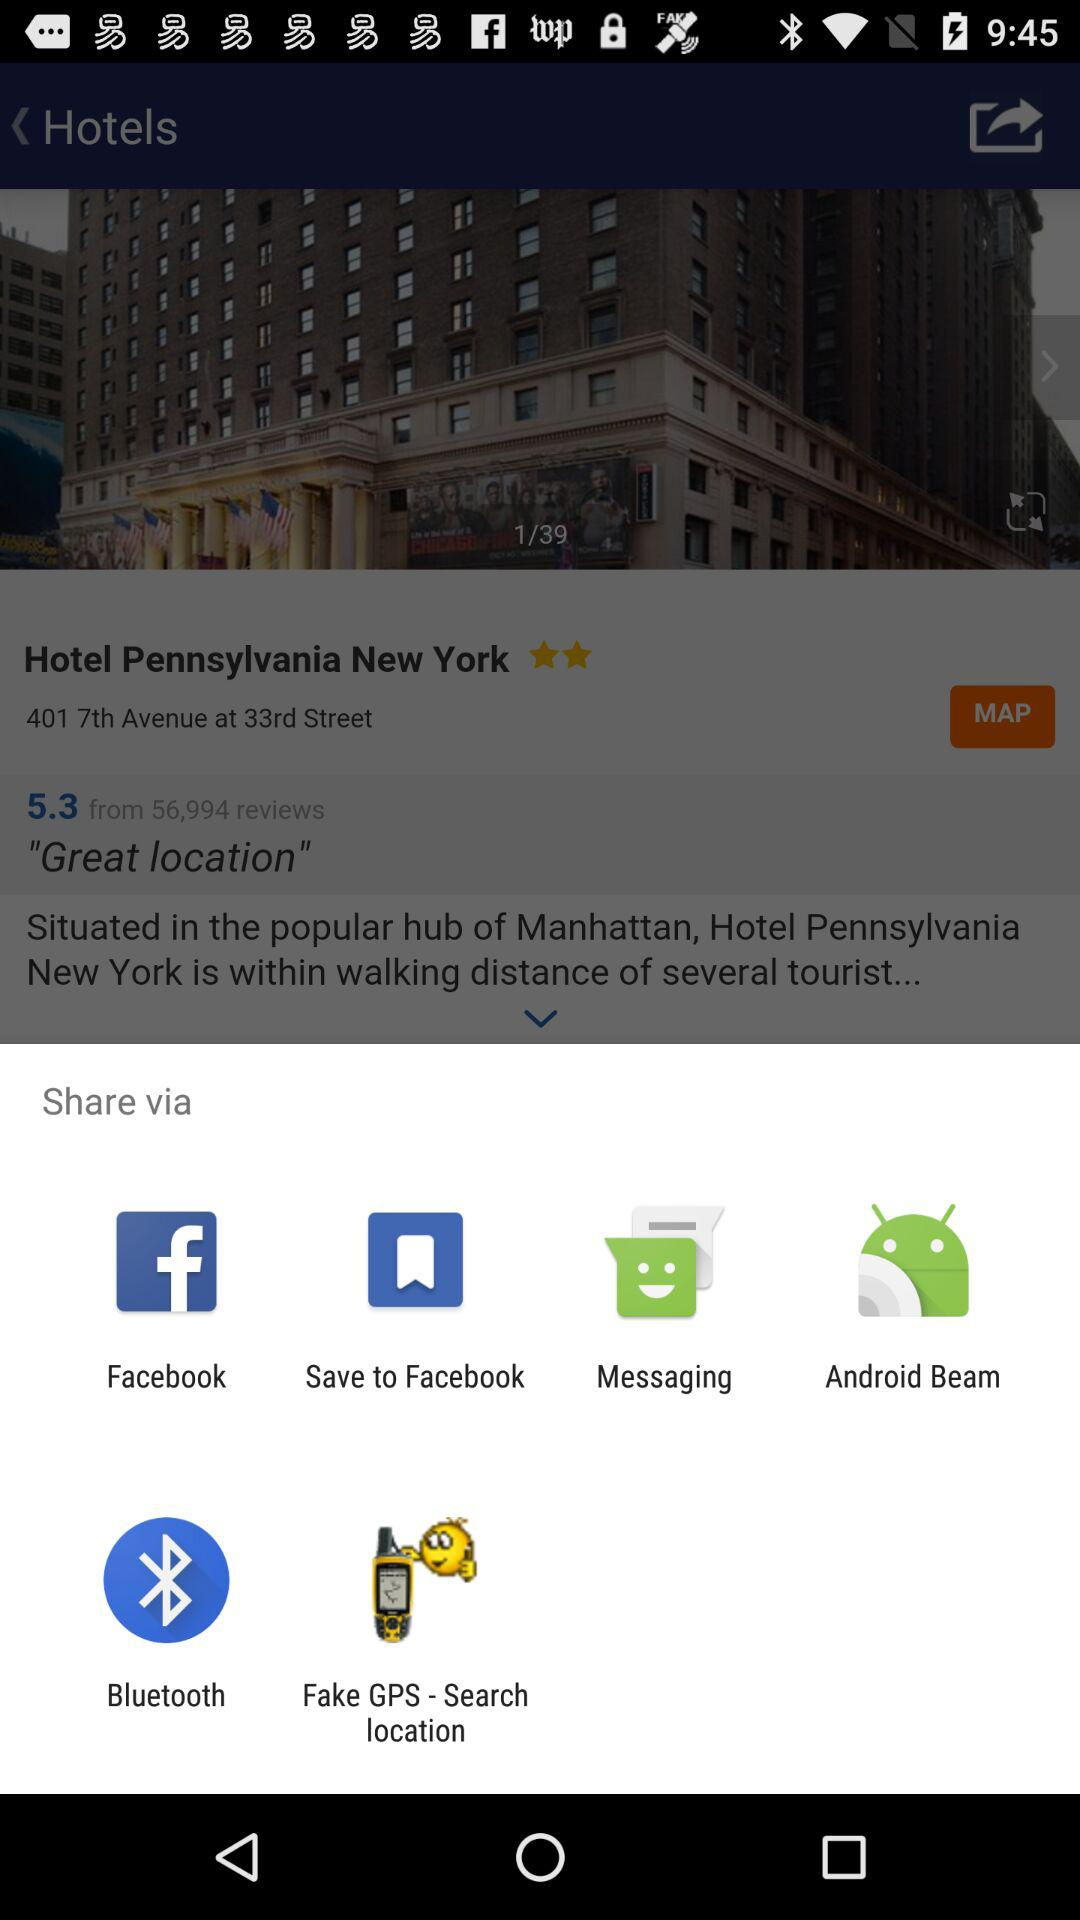How many reviews does Hotel Pennsylvania New York have?
Answer the question using a single word or phrase. 56,994 